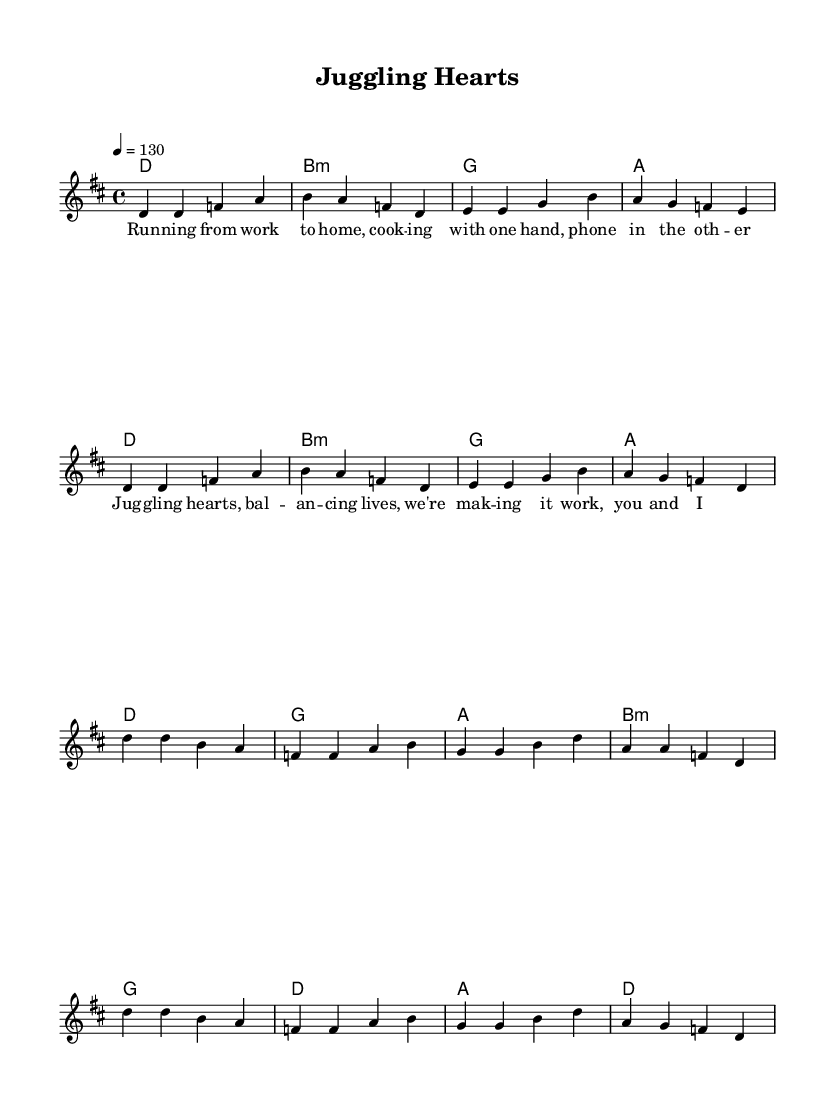What is the key signature of this music? The key signature is indicated at the beginning of the score, showing that it is in D major, which has two sharps: F# and C#.
Answer: D major What is the time signature of this music? The time signature is shown at the beginning, indicating that the piece is in 4/4, meaning there are four beats per measure and the quarter note gets one beat.
Answer: 4/4 What is the tempo marking for this piece? The tempo marking is found at the start of the score, indicating that the piece should be played at a speed of 130 beats per minute.
Answer: 130 How many measures are in the verse section? By counting the measures in the "Verse" part of the sheet music, there are a total of 8 measures shown before moving to the chorus.
Answer: 8 Which chords are used in the chorus section? The "Chorus" section lists the chords above the melody in the sheet music, which are D major, G major, A major, and B minor.
Answer: D, G, A, B minor What is the main theme of the lyrics? The lyrics focus on the struggles and balance of juggling work and family life, highlighting the constant movement and efforts of the individual.
Answer: Balancing work and family life What makes this piece characteristic of K-Pop? The upbeat tempo and relatable theme in the lyrics about daily life experiences resonate well with typical K-Pop songs, which often mix energetic music with personal storytelling.
Answer: Upbeat tempo and relatable lyrics 